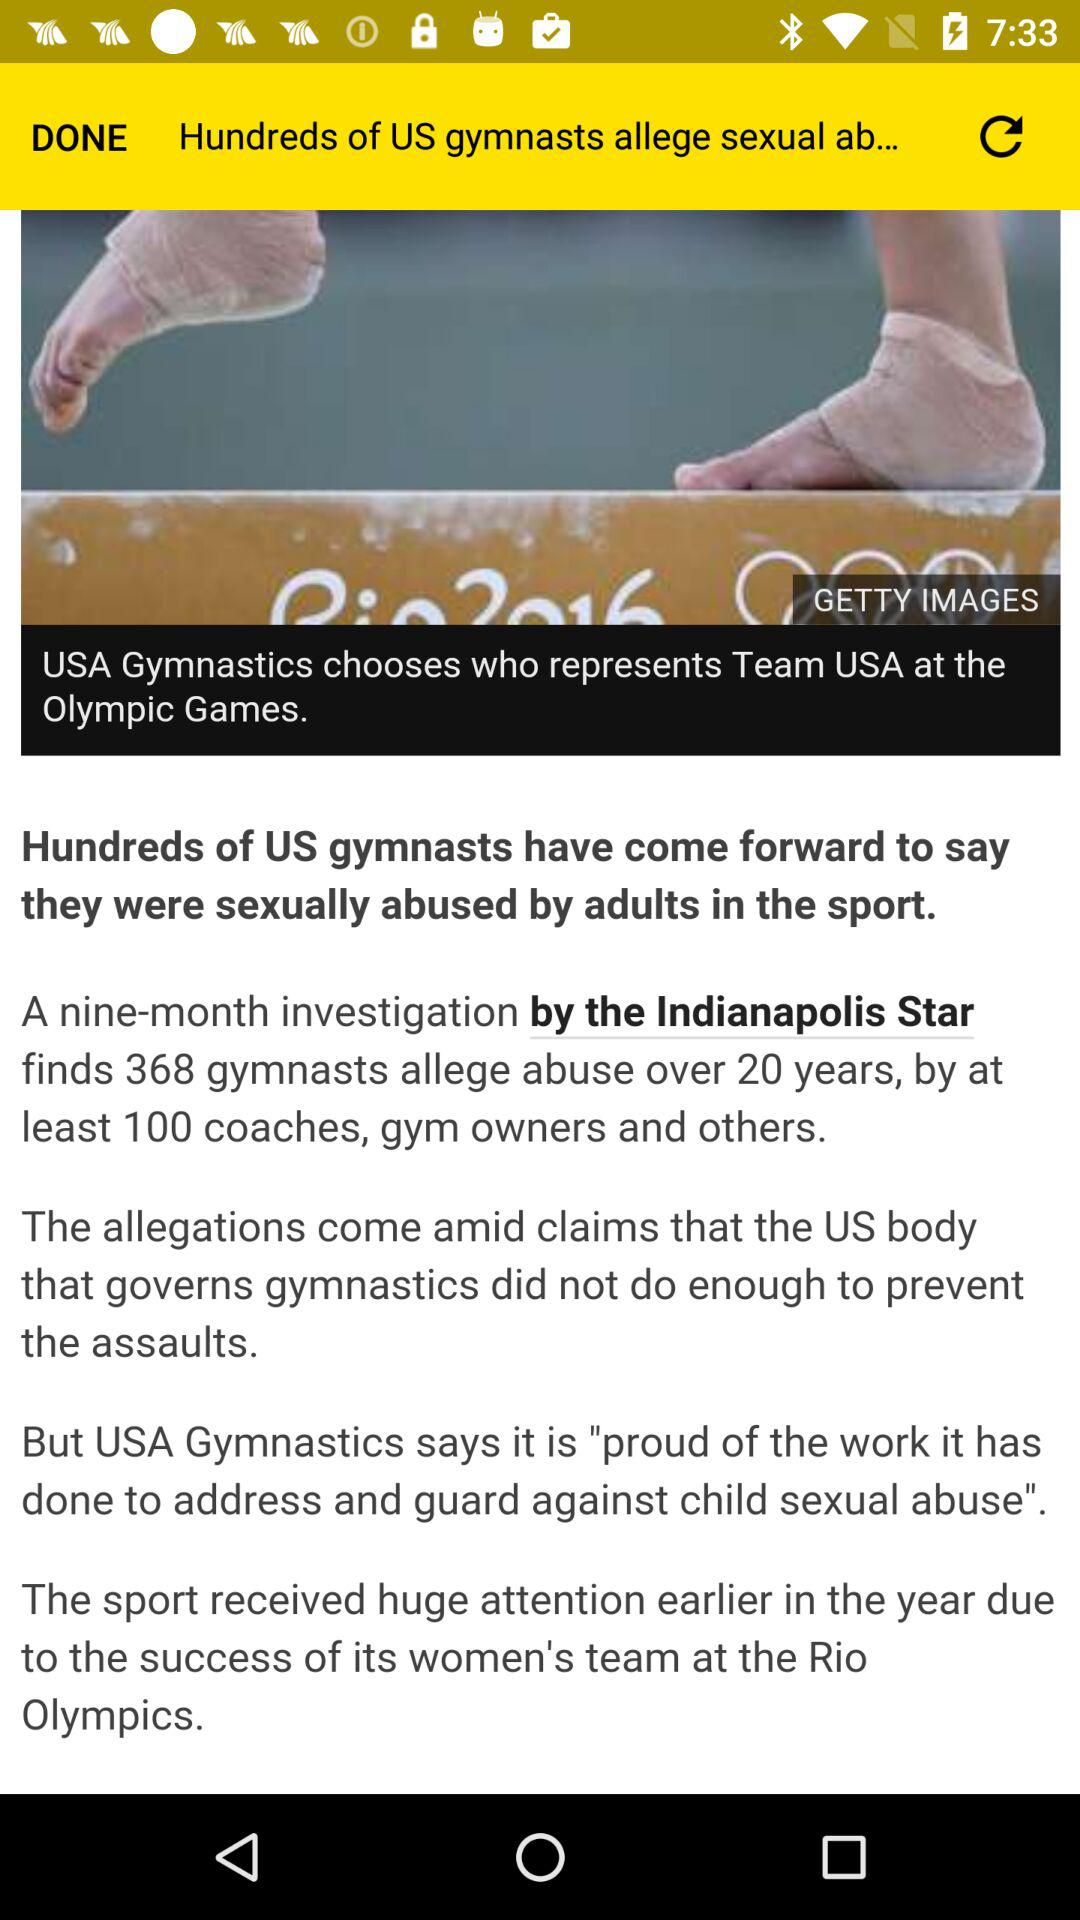How many months was the investigation done by the Indianapolis Star? The investigation done by the Indianapolis Star was done for nine months. 